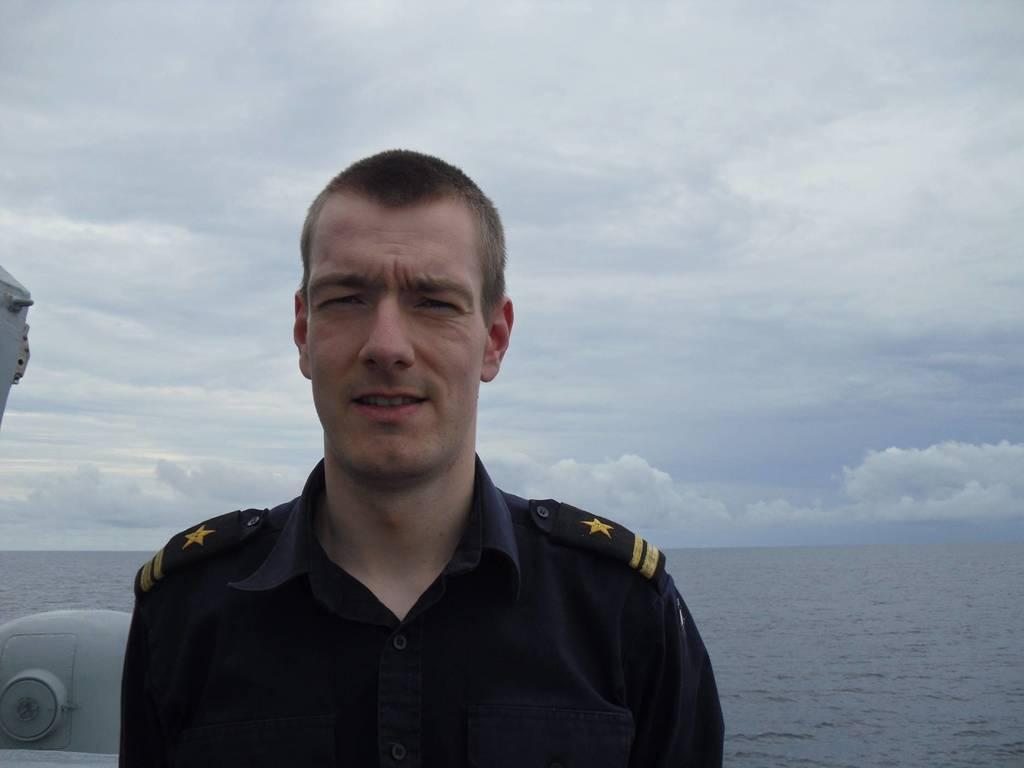How would you summarize this image in a sentence or two? In this image there is the sky, there are clouds in the sky, there is sea truncated towards the right of the image, there is a person truncated towards the bottom of the image, there is an object truncated towards the left of the image. 